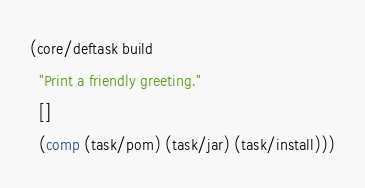<code> <loc_0><loc_0><loc_500><loc_500><_Clojure_>(core/deftask build
  "Print a friendly greeting."
  []
  (comp (task/pom) (task/jar) (task/install)))
</code> 